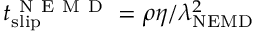Convert formula to latex. <formula><loc_0><loc_0><loc_500><loc_500>t _ { s l i p } ^ { N E M D } = \rho \eta / \lambda _ { N E M D } ^ { 2 }</formula> 